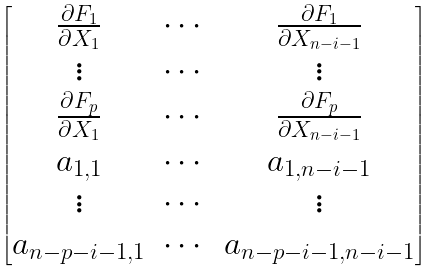Convert formula to latex. <formula><loc_0><loc_0><loc_500><loc_500>\begin{bmatrix} \frac { \partial F _ { 1 } } { \partial X _ { 1 } } & \cdots & \frac { \partial F _ { 1 } } { \partial X _ { n - i - 1 } } \\ \vdots & \cdots & \vdots \\ \frac { \partial F _ { p } } { \partial X _ { 1 } } & \cdots & \frac { \partial F _ { p } } { \partial X _ { n - i - 1 } } \\ a _ { 1 , 1 } & \cdots & a _ { 1 , n - i - 1 } \\ \vdots & \cdots & \vdots \\ a _ { n - p - i - 1 , 1 } & \cdots & a _ { n - p - i - 1 , n - i - 1 } \\ \end{bmatrix}</formula> 